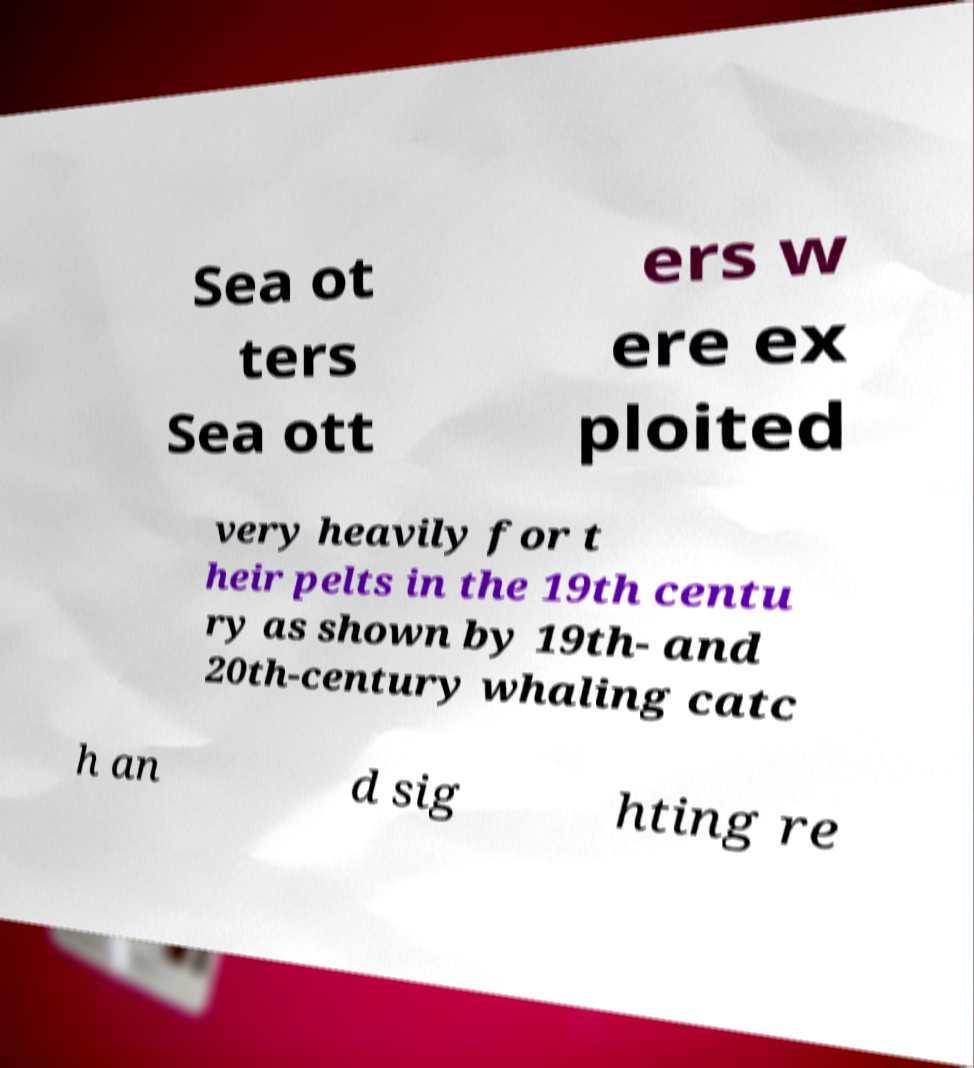Could you assist in decoding the text presented in this image and type it out clearly? Sea ot ters Sea ott ers w ere ex ploited very heavily for t heir pelts in the 19th centu ry as shown by 19th- and 20th-century whaling catc h an d sig hting re 